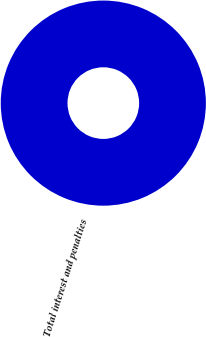<chart> <loc_0><loc_0><loc_500><loc_500><pie_chart><fcel>Total interest and penalties<nl><fcel>100.0%<nl></chart> 